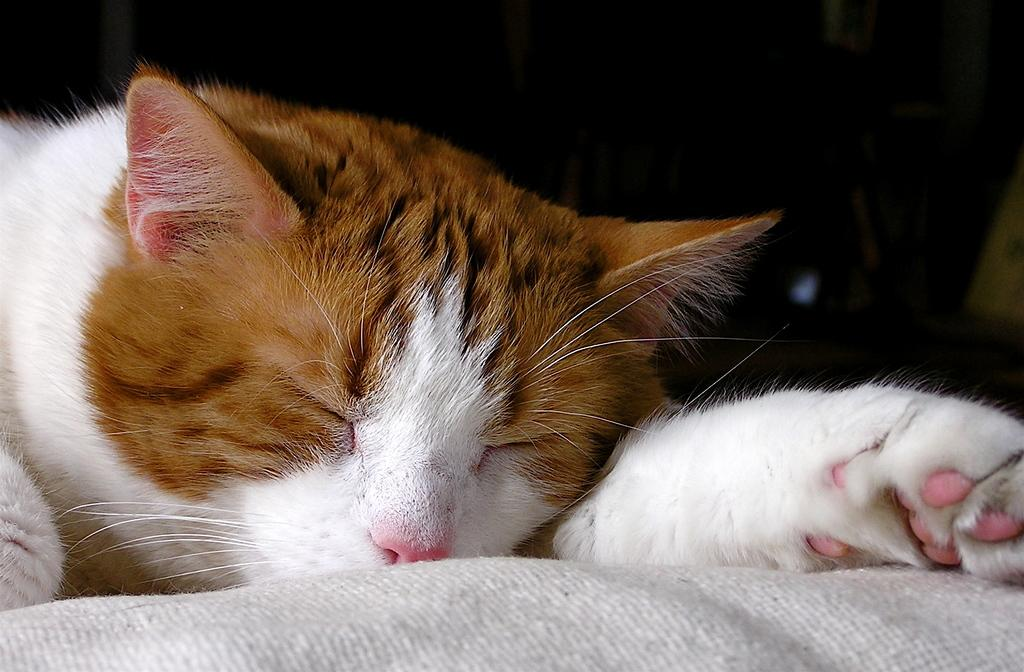What type of animal is in the image? There is a cat in the image. What is the cat doing in the image? The cat is sleeping. On what surface is the cat resting? The cat is on a surface. Can you describe the object that is truncated towards the bottom of the image? Unfortunately, we cannot provide a description of the truncated object, as it is not fully visible in the image. What is the color of the background in the image? The background of the image is dark. How does the cat show respect to the doll in the image? There is no doll present in the image, so the cat cannot show respect to a doll. 